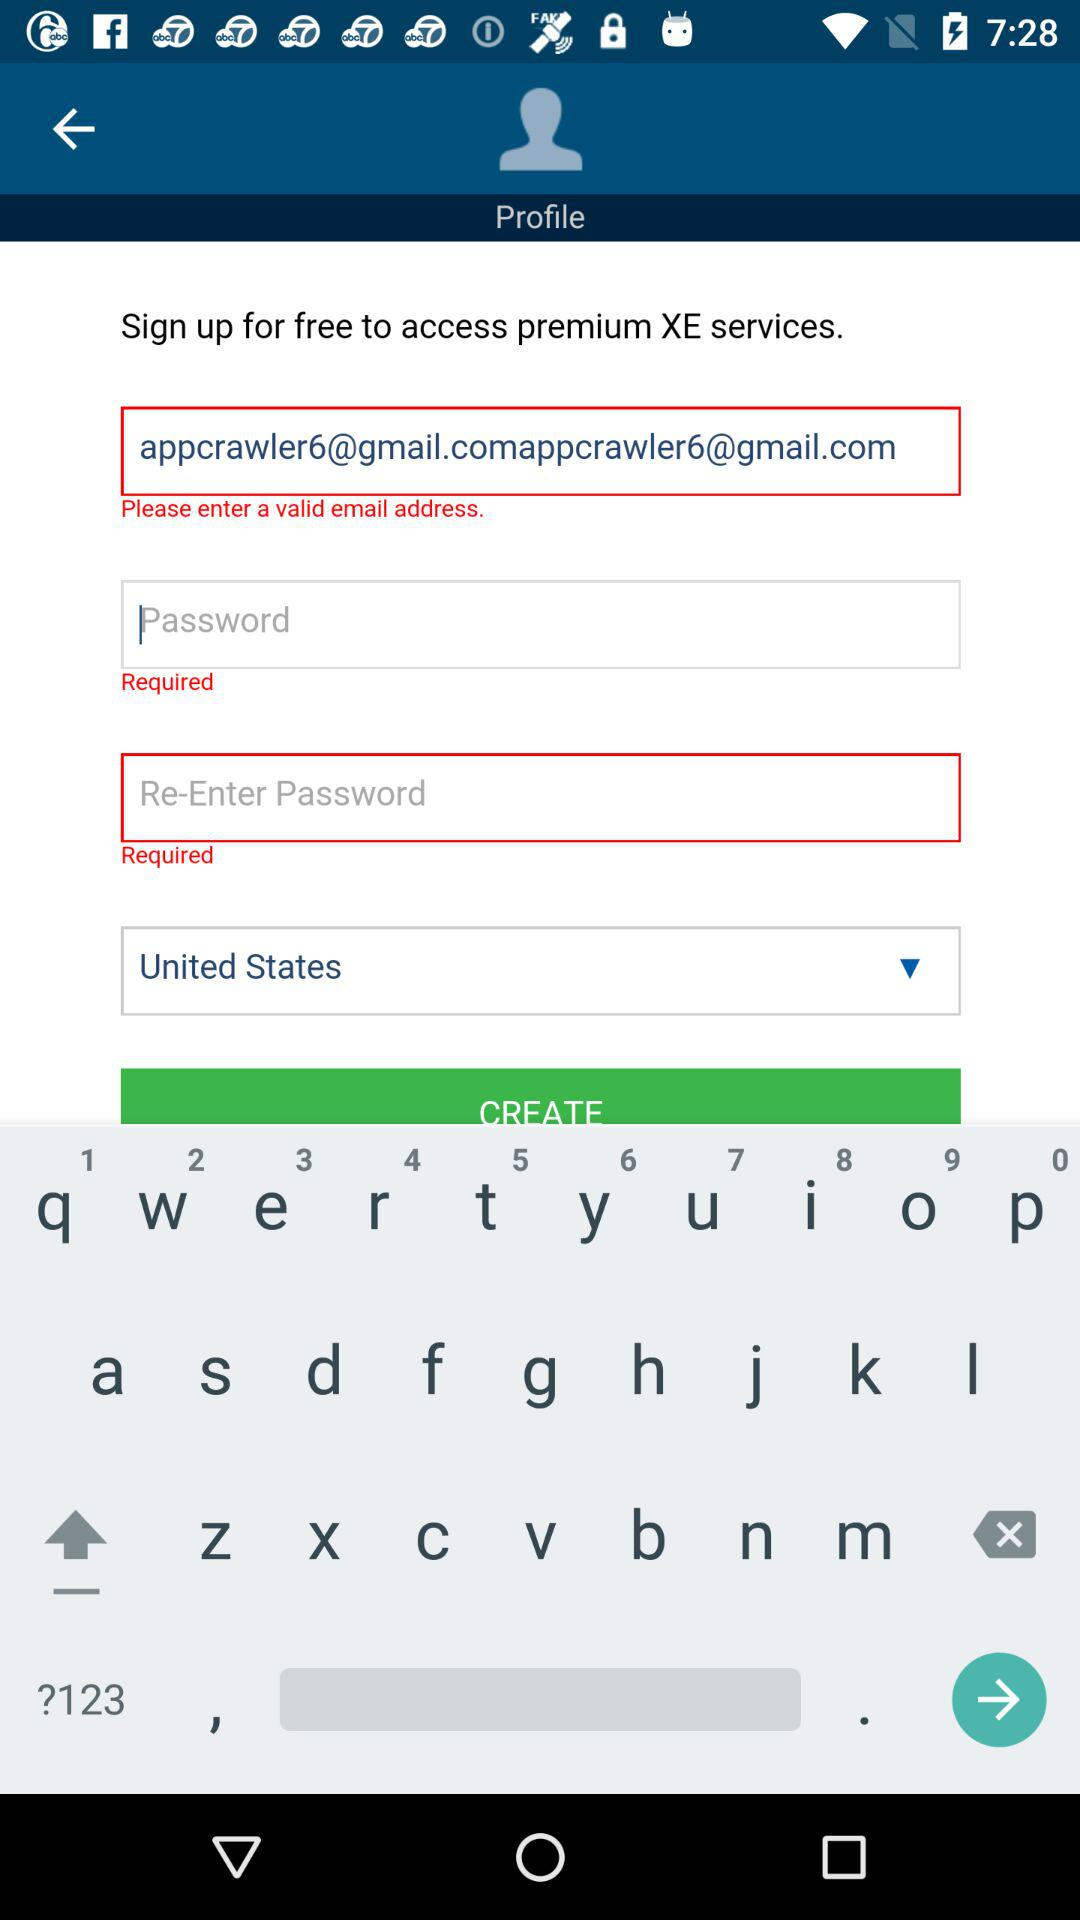Which country is selected? The selected country is the United States. 